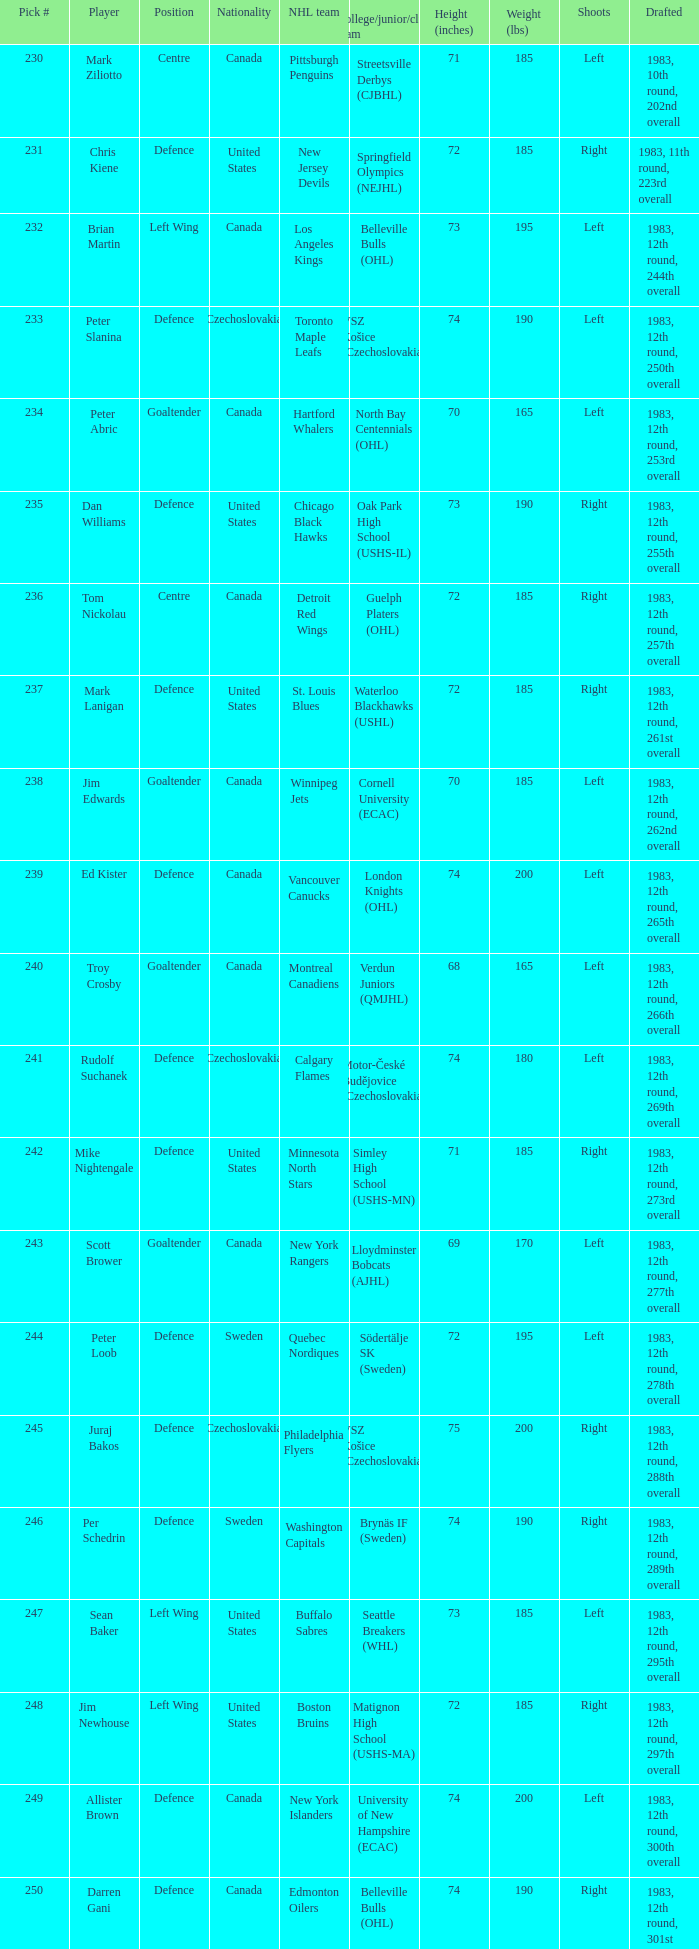What position does allister brown play. Defence. 